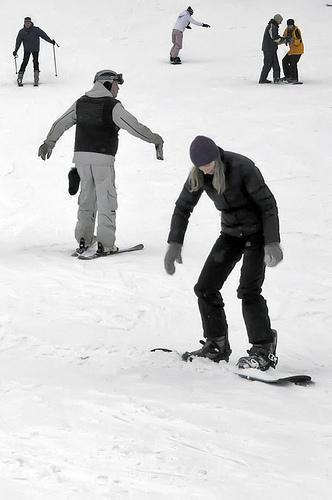What skill level do most snowboarders here have?
Make your selection and explain in format: 'Answer: answer
Rationale: rationale.'
Options: Beginners, professional, olympic, competitive. Answer: beginners.
Rationale: Most of the snowboarders are basic beginners. 